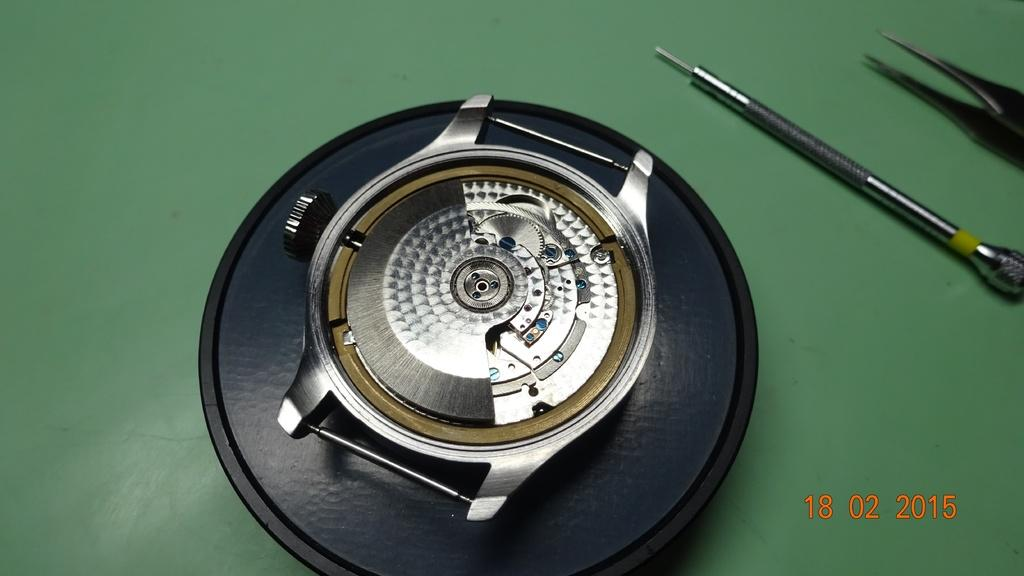What is the main subject of the picture? The main subject of the picture is a watch dial. What else can be seen in the picture besides the watch dial? There are instruments visible in the picture. Where is the text located in the picture? The text is at the right bottom of the picture. How many pears are floating in the water near the instruments in the picture? There are no pears visible in the picture; it only features a watch dial, instruments, and text. What type of punishment is being administered to the boats in the picture? There are no boats present in the picture, so it is not possible to determine if any punishment is being administered. 